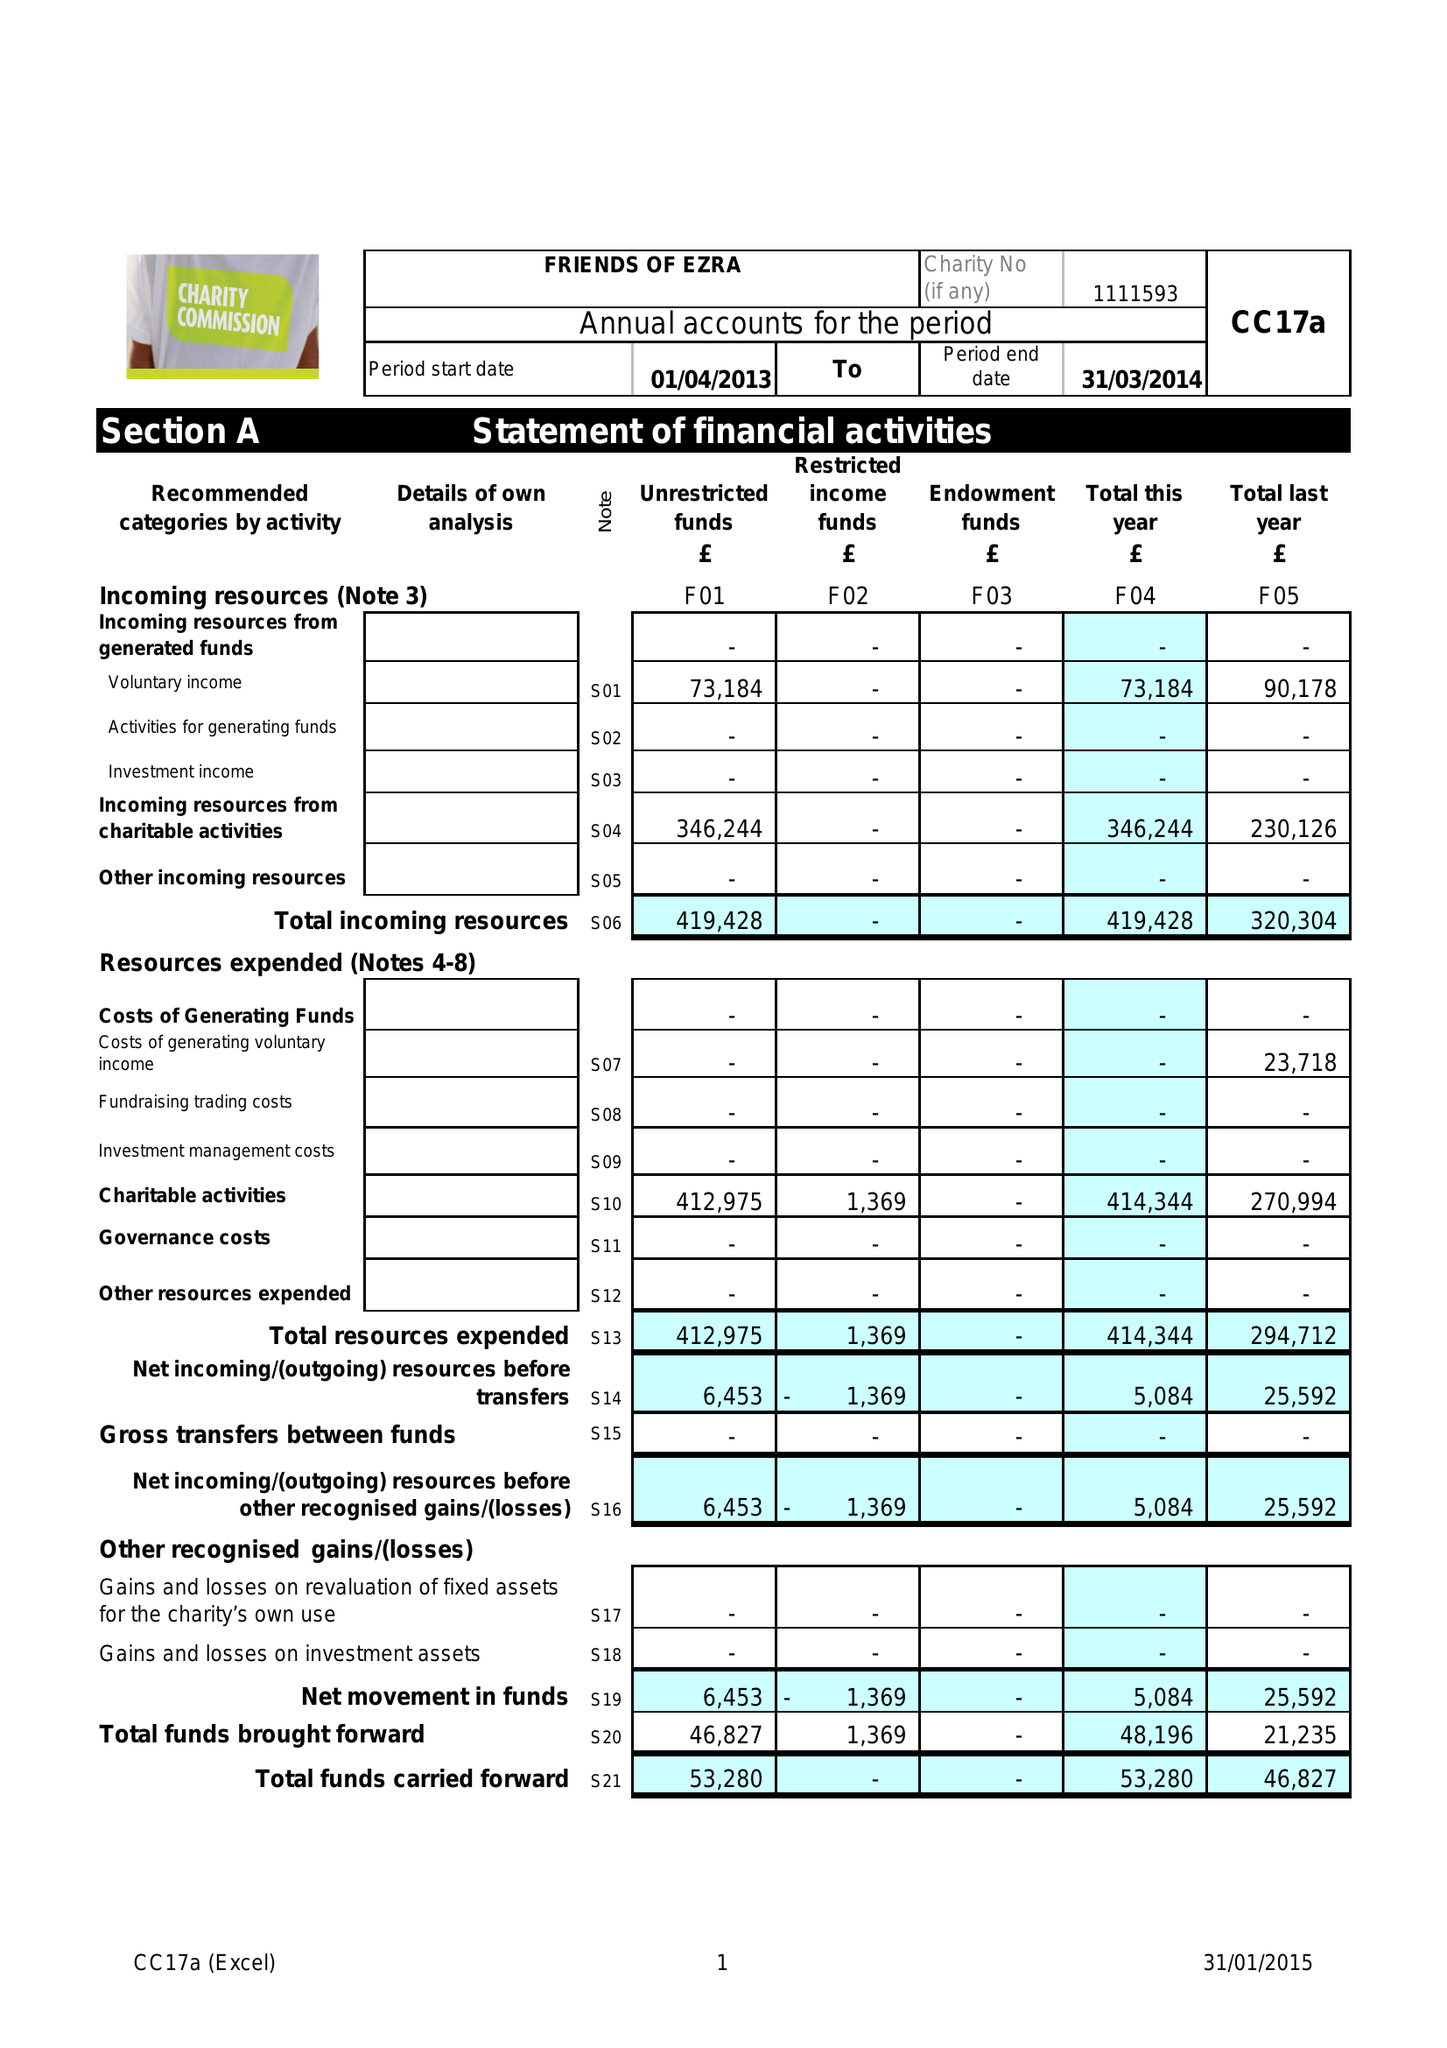What is the value for the report_date?
Answer the question using a single word or phrase. 2014-03-31 